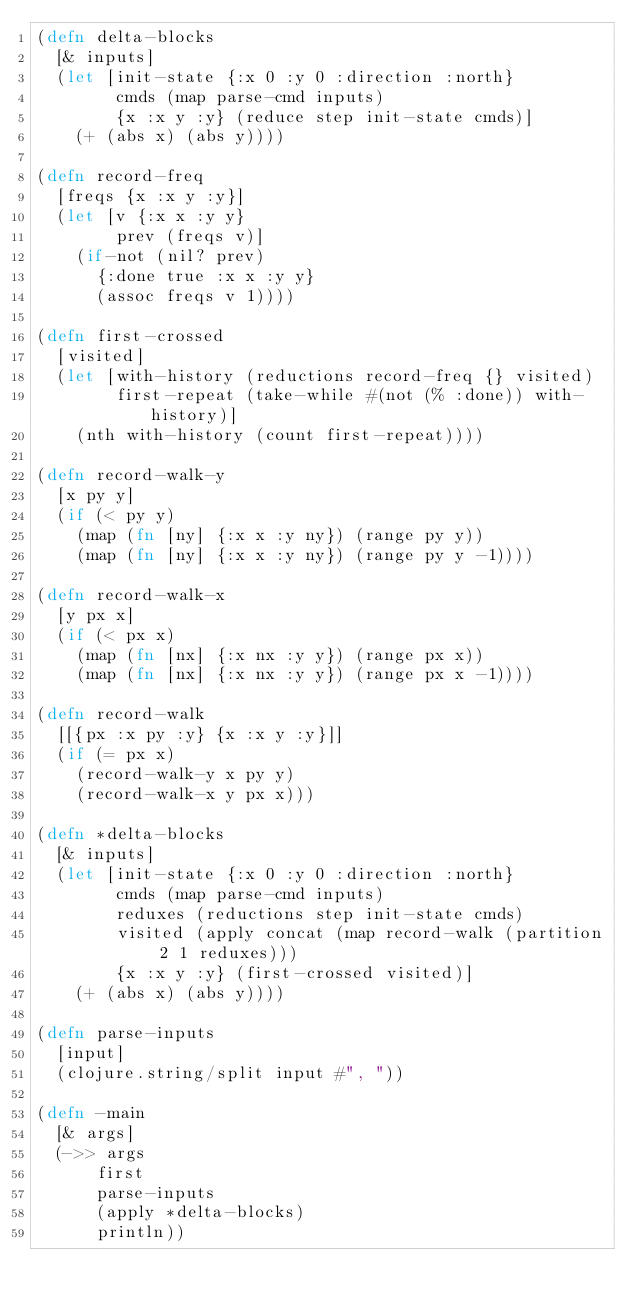<code> <loc_0><loc_0><loc_500><loc_500><_Clojure_>(defn delta-blocks
  [& inputs]
  (let [init-state {:x 0 :y 0 :direction :north}
        cmds (map parse-cmd inputs)
        {x :x y :y} (reduce step init-state cmds)]
    (+ (abs x) (abs y))))

(defn record-freq
  [freqs {x :x y :y}]
  (let [v {:x x :y y}
        prev (freqs v)]
    (if-not (nil? prev)
      {:done true :x x :y y}
      (assoc freqs v 1))))

(defn first-crossed
  [visited]
  (let [with-history (reductions record-freq {} visited)
        first-repeat (take-while #(not (% :done)) with-history)]
    (nth with-history (count first-repeat))))

(defn record-walk-y
  [x py y]
  (if (< py y)
    (map (fn [ny] {:x x :y ny}) (range py y))
    (map (fn [ny] {:x x :y ny}) (range py y -1))))

(defn record-walk-x
  [y px x]
  (if (< px x)
    (map (fn [nx] {:x nx :y y}) (range px x))
    (map (fn [nx] {:x nx :y y}) (range px x -1))))

(defn record-walk
  [[{px :x py :y} {x :x y :y}]]
  (if (= px x)
    (record-walk-y x py y)
    (record-walk-x y px x)))

(defn *delta-blocks
  [& inputs]
  (let [init-state {:x 0 :y 0 :direction :north}
        cmds (map parse-cmd inputs)
        reduxes (reductions step init-state cmds)
        visited (apply concat (map record-walk (partition 2 1 reduxes)))
        {x :x y :y} (first-crossed visited)]
    (+ (abs x) (abs y))))

(defn parse-inputs
  [input]
  (clojure.string/split input #", "))

(defn -main
  [& args]
  (->> args
      first
      parse-inputs
      (apply *delta-blocks)
      println))
</code> 